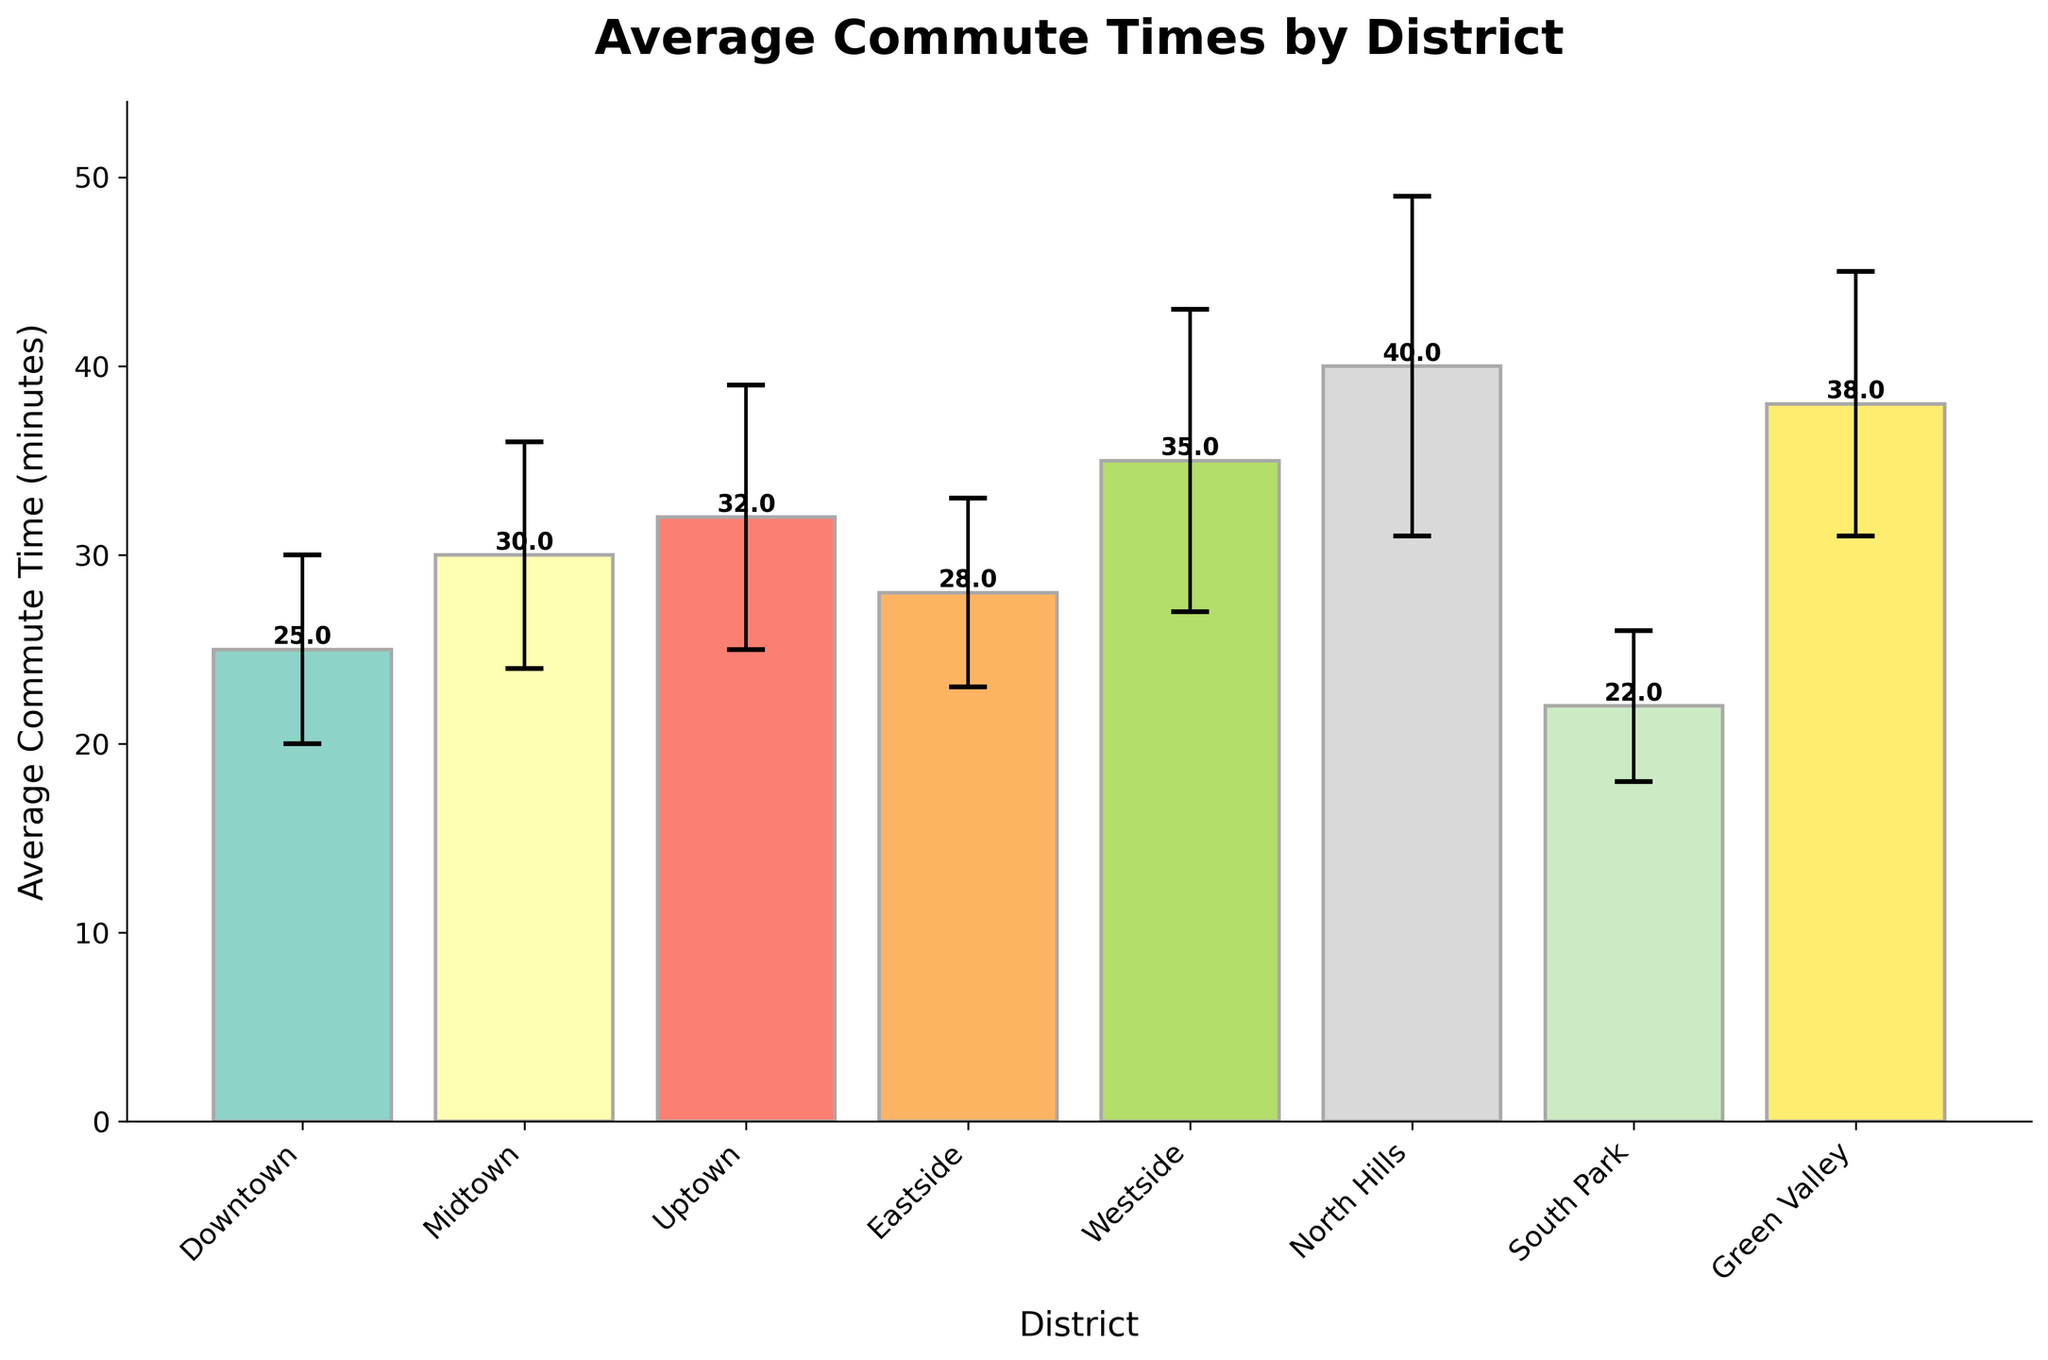What is the title of the figure? The title of the figure is displayed at the top and reads 'Average Commute Times by District'.
Answer: Average Commute Times by District Which district has the longest average commute time? The district with the tallest bar in the figure represents the longest average commute time. This is the North Hills district.
Answer: North Hills How many districts are shown in the figure? Each bar in the chart represents a district, and there are a total of 8 bars.
Answer: 8 What is the average commute time for the Downtown district? Look for the bar labeled Downtown and read the numerical value associated with it, which is 25 minutes.
Answer: 25 minutes Which district has the shortest average commute time? The district with the shortest bar in the figure represents the shortest average commute time, which is South Park.
Answer: South Park What is the average commute time difference between North Hills and South Park? Subtract the average commute time of South Park (22 minutes) from North Hills (40 minutes). So, the difference is 40 - 22 = 18 minutes.
Answer: 18 minutes Does Midtown have a commute time greater than Uptown? Compare the bars for Midtown and Uptown. Midtown's bar is marked at 30 minutes, while Uptown's bar is higher at 32 minutes. So, Midtown does not have a greater commute time.
Answer: No Which district has the largest variation in commute time? The size of the error bars indicates variation. The largest error bar belongs to North Hills.
Answer: North Hills What is the average of the commute times for Eastside and Westside? Add the average commute times of Eastside (28 minutes) and Westside (35 minutes), and then divide by 2: (28 + 35) / 2 = 31.5 minutes.
Answer: 31.5 minutes Is the commute time for Green Valley within one standard deviation of the Downtown district's commute time? Green Valley's time is 38 minutes. Downtown's time of 25 minutes, plus one standard deviation of 5 minutes, results in 25 + 5 = 30 minutes. 38 is not within this range.
Answer: No 